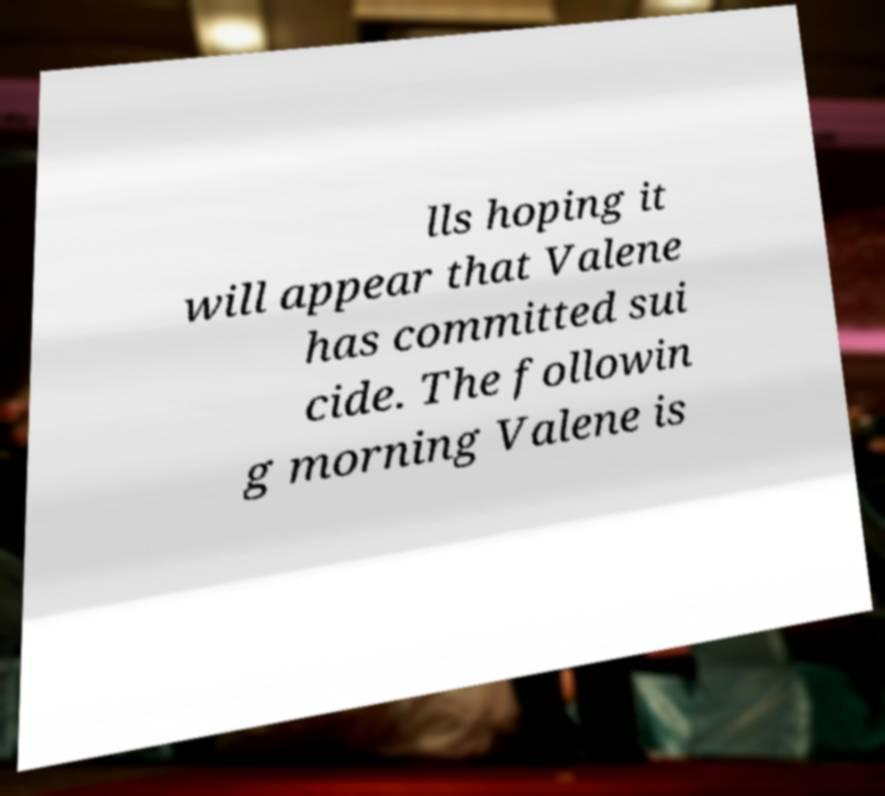Could you assist in decoding the text presented in this image and type it out clearly? lls hoping it will appear that Valene has committed sui cide. The followin g morning Valene is 